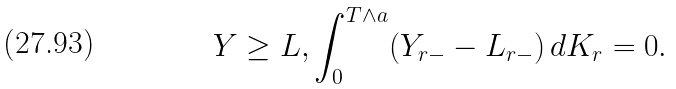<formula> <loc_0><loc_0><loc_500><loc_500>Y \geq L , \int _ { 0 } ^ { T \wedge a } ( Y _ { r - } - L _ { r - } ) \, d K _ { r } = 0 .</formula> 